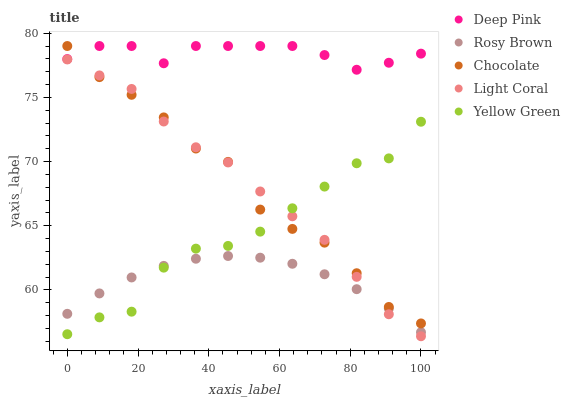Does Rosy Brown have the minimum area under the curve?
Answer yes or no. Yes. Does Deep Pink have the maximum area under the curve?
Answer yes or no. Yes. Does Deep Pink have the minimum area under the curve?
Answer yes or no. No. Does Rosy Brown have the maximum area under the curve?
Answer yes or no. No. Is Rosy Brown the smoothest?
Answer yes or no. Yes. Is Yellow Green the roughest?
Answer yes or no. Yes. Is Deep Pink the smoothest?
Answer yes or no. No. Is Deep Pink the roughest?
Answer yes or no. No. Does Light Coral have the lowest value?
Answer yes or no. Yes. Does Rosy Brown have the lowest value?
Answer yes or no. No. Does Chocolate have the highest value?
Answer yes or no. Yes. Does Rosy Brown have the highest value?
Answer yes or no. No. Is Rosy Brown less than Chocolate?
Answer yes or no. Yes. Is Deep Pink greater than Yellow Green?
Answer yes or no. Yes. Does Light Coral intersect Yellow Green?
Answer yes or no. Yes. Is Light Coral less than Yellow Green?
Answer yes or no. No. Is Light Coral greater than Yellow Green?
Answer yes or no. No. Does Rosy Brown intersect Chocolate?
Answer yes or no. No. 